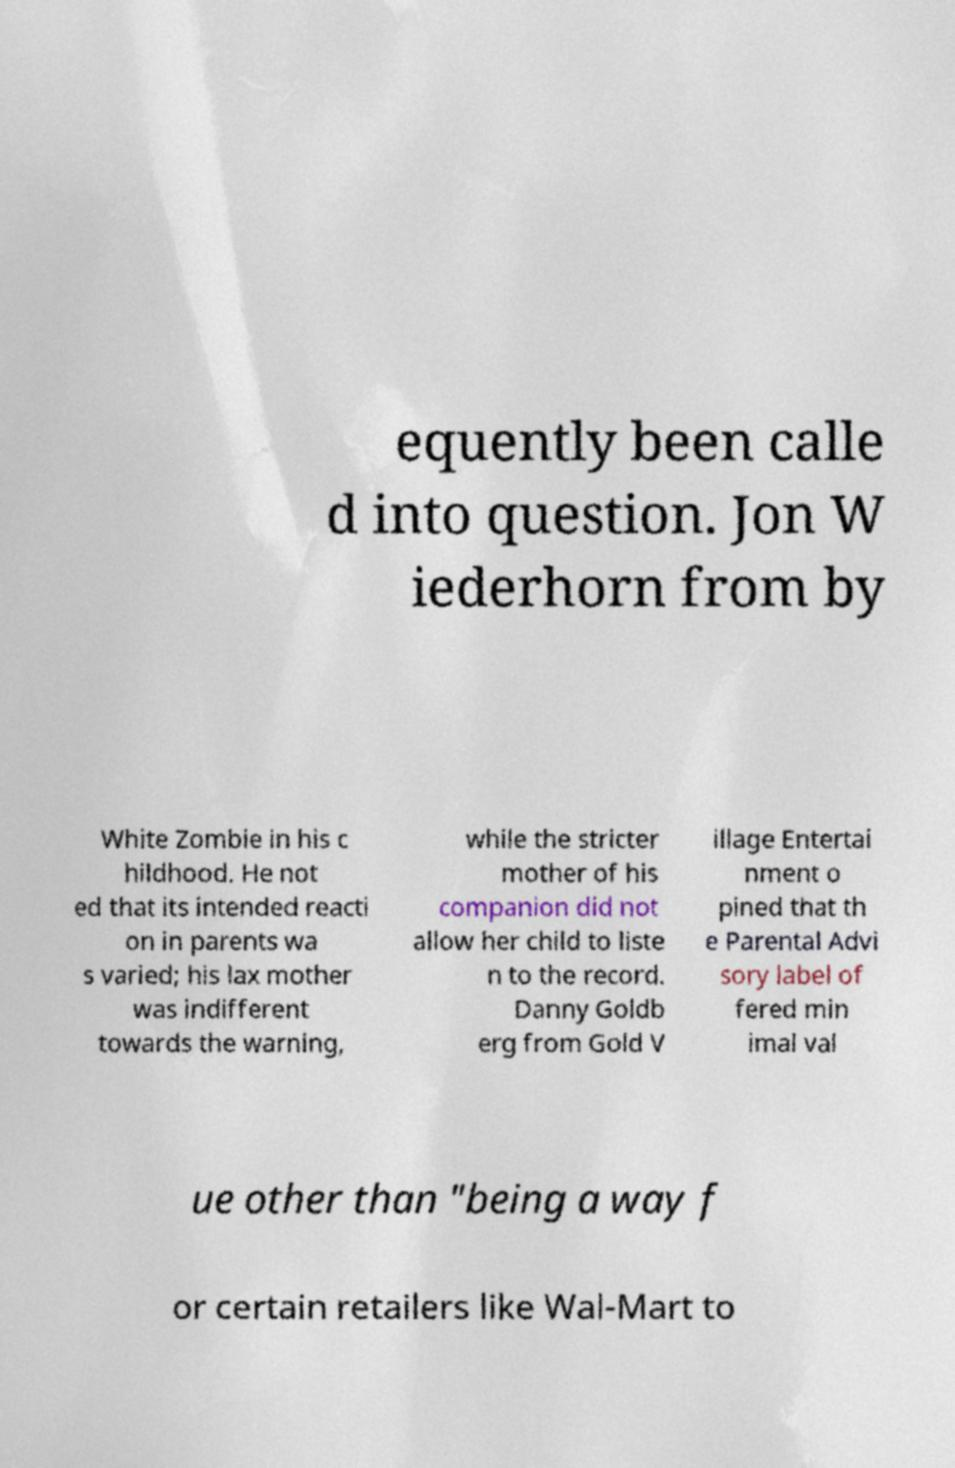Could you assist in decoding the text presented in this image and type it out clearly? equently been calle d into question. Jon W iederhorn from by White Zombie in his c hildhood. He not ed that its intended reacti on in parents wa s varied; his lax mother was indifferent towards the warning, while the stricter mother of his companion did not allow her child to liste n to the record. Danny Goldb erg from Gold V illage Entertai nment o pined that th e Parental Advi sory label of fered min imal val ue other than "being a way f or certain retailers like Wal-Mart to 